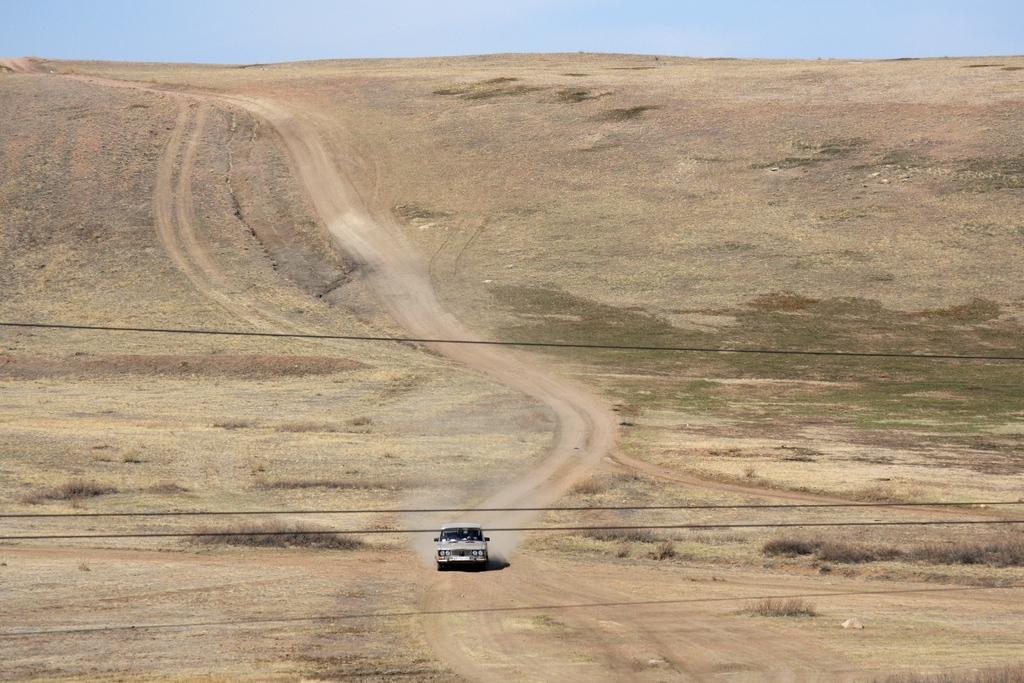How would you summarize this image in a sentence or two? In the picture I can see a vehicle on the ground. I can also see wires and the grass. In the background I can see the sky. 